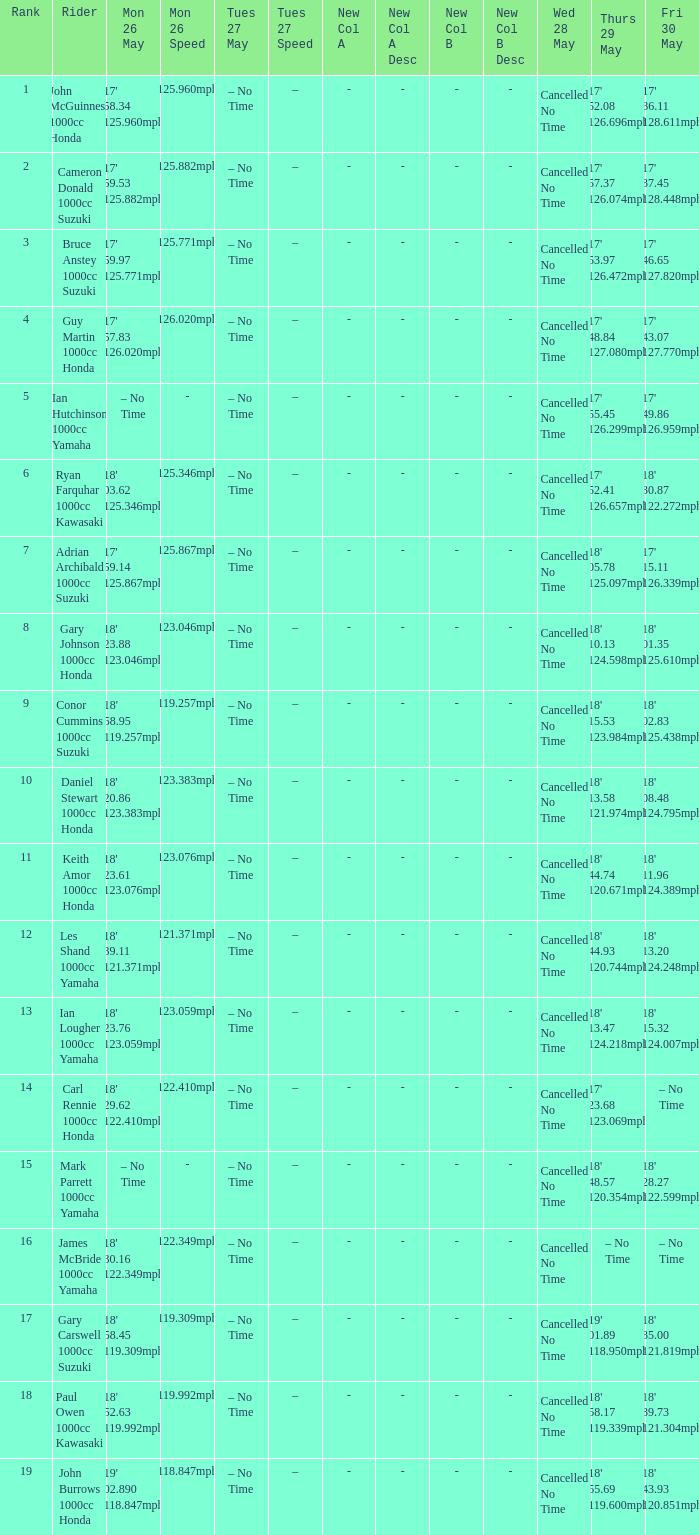What tims is wed may 28 and mon may 26 is 17' 58.34 125.960mph? Cancelled No Time. 